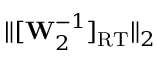Convert formula to latex. <formula><loc_0><loc_0><loc_500><loc_500>\| [ W _ { 2 } ^ { - 1 } ] _ { R T } \| _ { 2 }</formula> 